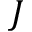<formula> <loc_0><loc_0><loc_500><loc_500>J</formula> 